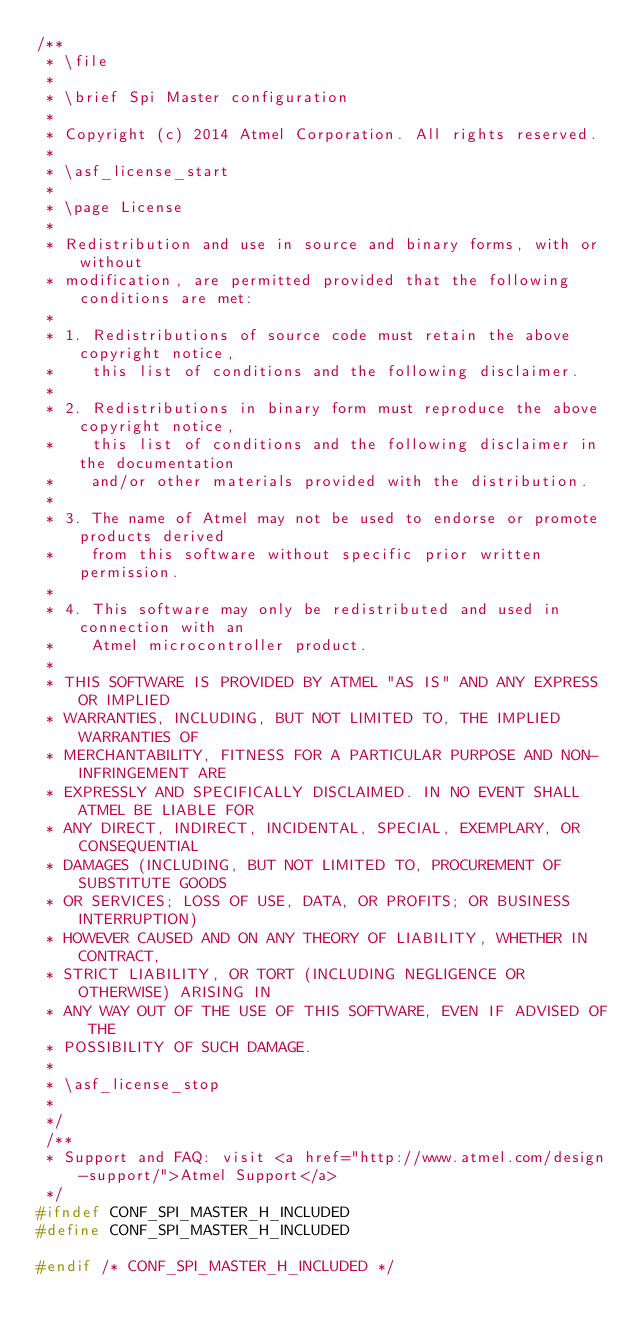<code> <loc_0><loc_0><loc_500><loc_500><_C_>/**
 * \file
 *
 * \brief Spi Master configuration
 *
 * Copyright (c) 2014 Atmel Corporation. All rights reserved.
 *
 * \asf_license_start
 *
 * \page License
 *
 * Redistribution and use in source and binary forms, with or without
 * modification, are permitted provided that the following conditions are met:
 *
 * 1. Redistributions of source code must retain the above copyright notice,
 *    this list of conditions and the following disclaimer.
 *
 * 2. Redistributions in binary form must reproduce the above copyright notice,
 *    this list of conditions and the following disclaimer in the documentation
 *    and/or other materials provided with the distribution.
 *
 * 3. The name of Atmel may not be used to endorse or promote products derived
 *    from this software without specific prior written permission.
 *
 * 4. This software may only be redistributed and used in connection with an
 *    Atmel microcontroller product.
 *
 * THIS SOFTWARE IS PROVIDED BY ATMEL "AS IS" AND ANY EXPRESS OR IMPLIED
 * WARRANTIES, INCLUDING, BUT NOT LIMITED TO, THE IMPLIED WARRANTIES OF
 * MERCHANTABILITY, FITNESS FOR A PARTICULAR PURPOSE AND NON-INFRINGEMENT ARE
 * EXPRESSLY AND SPECIFICALLY DISCLAIMED. IN NO EVENT SHALL ATMEL BE LIABLE FOR
 * ANY DIRECT, INDIRECT, INCIDENTAL, SPECIAL, EXEMPLARY, OR CONSEQUENTIAL
 * DAMAGES (INCLUDING, BUT NOT LIMITED TO, PROCUREMENT OF SUBSTITUTE GOODS
 * OR SERVICES; LOSS OF USE, DATA, OR PROFITS; OR BUSINESS INTERRUPTION)
 * HOWEVER CAUSED AND ON ANY THEORY OF LIABILITY, WHETHER IN CONTRACT,
 * STRICT LIABILITY, OR TORT (INCLUDING NEGLIGENCE OR OTHERWISE) ARISING IN
 * ANY WAY OUT OF THE USE OF THIS SOFTWARE, EVEN IF ADVISED OF THE
 * POSSIBILITY OF SUCH DAMAGE.
 *
 * \asf_license_stop
 *
 */
 /**
 * Support and FAQ: visit <a href="http://www.atmel.com/design-support/">Atmel Support</a>
 */
#ifndef CONF_SPI_MASTER_H_INCLUDED
#define CONF_SPI_MASTER_H_INCLUDED

#endif /* CONF_SPI_MASTER_H_INCLUDED */
</code> 